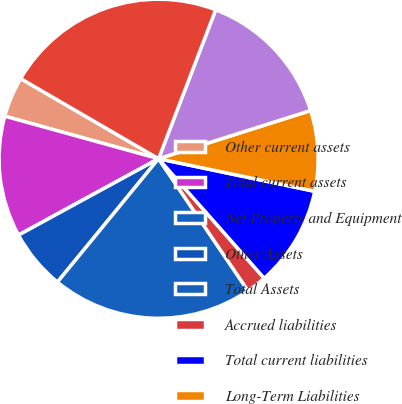Convert chart. <chart><loc_0><loc_0><loc_500><loc_500><pie_chart><fcel>Other current assets<fcel>Total current assets<fcel>Net Property and Equipment<fcel>Other Assets<fcel>Total Assets<fcel>Accrued liabilities<fcel>Total current liabilities<fcel>Long-Term Liabilities<fcel>Shareholders' Equity<fcel>Total Liabilities and<nl><fcel>4.08%<fcel>12.24%<fcel>0.0%<fcel>6.12%<fcel>20.4%<fcel>2.04%<fcel>10.2%<fcel>8.16%<fcel>14.28%<fcel>22.44%<nl></chart> 